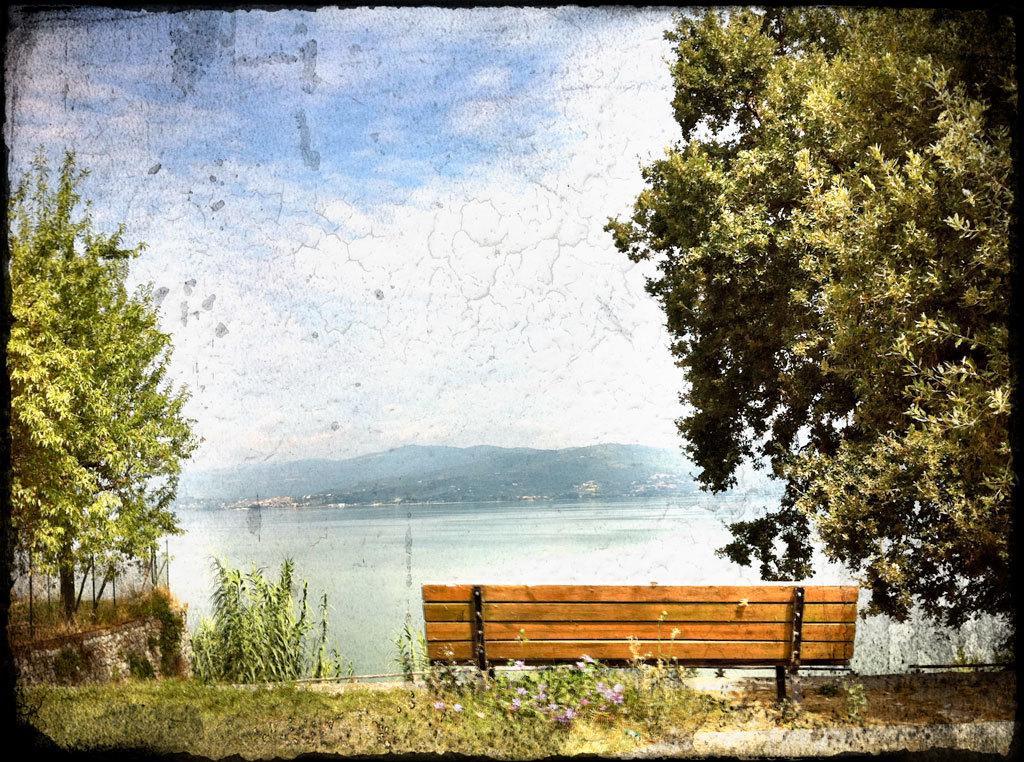Please provide a concise description of this image. In the foreground of this image, there are few flowers, a bench and few trees. In the background, there is water, mountains and the sky. We can also see black borders to this image. 